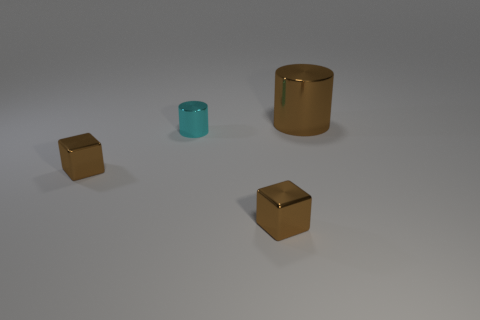Add 2 small purple matte cylinders. How many objects exist? 6 Add 3 yellow shiny cylinders. How many yellow shiny cylinders exist? 3 Subtract 0 purple blocks. How many objects are left? 4 Subtract all large red objects. Subtract all big brown metal cylinders. How many objects are left? 3 Add 4 tiny cyan cylinders. How many tiny cyan cylinders are left? 5 